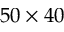Convert formula to latex. <formula><loc_0><loc_0><loc_500><loc_500>5 0 \times 4 0</formula> 